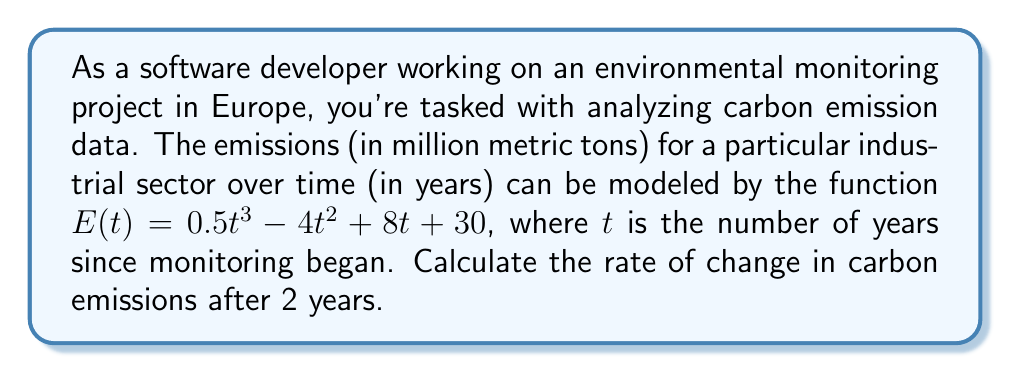Could you help me with this problem? To find the rate of change in carbon emissions after 2 years, we need to follow these steps:

1. The rate of change is represented by the derivative of the function $E(t)$.

2. Let's find the derivative $E'(t)$:
   $$E'(t) = \frac{d}{dt}(0.5t^3 - 4t^2 + 8t + 30)$$
   $$E'(t) = 1.5t^2 - 8t + 8$$

3. Now that we have the derivative, we can calculate the rate of change at $t = 2$ years:
   $$E'(2) = 1.5(2)^2 - 8(2) + 8$$
   $$E'(2) = 1.5(4) - 16 + 8$$
   $$E'(2) = 6 - 16 + 8$$
   $$E'(2) = -2$$

4. The negative value indicates that the emissions are decreasing at this point in time.
Answer: $-2$ million metric tons per year 